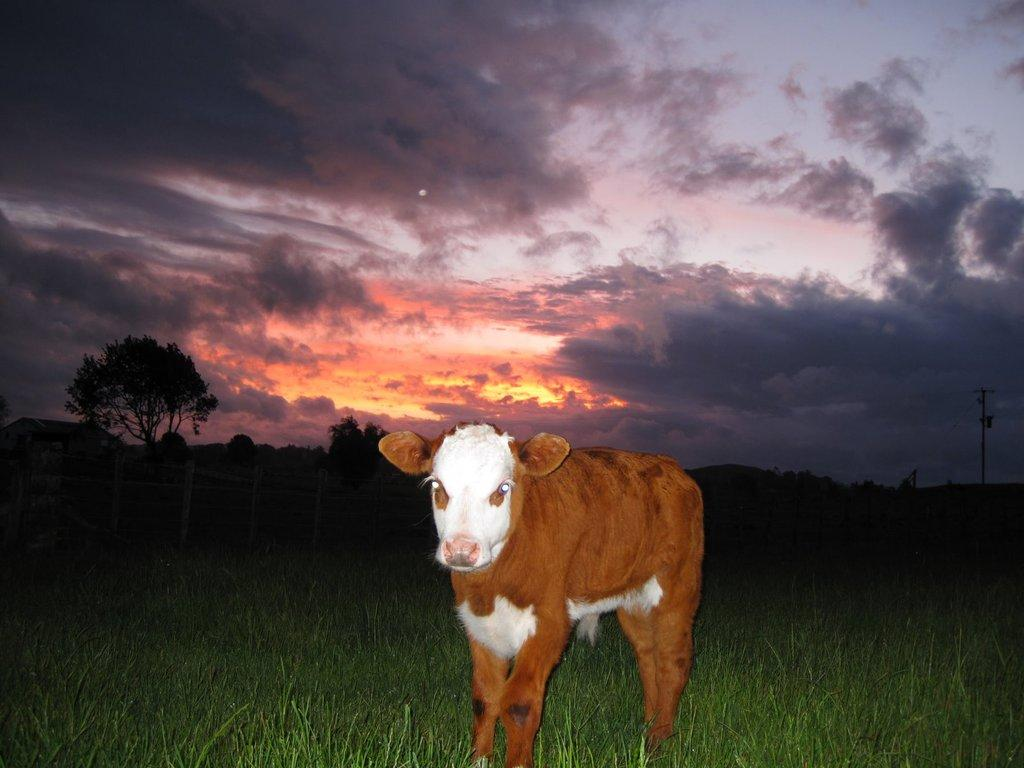What type of animal is in the image? There is a calf in the image. What can be seen in the background of the image? There are trees in the image. What is on the ground in the image? There is grass on the ground in the image. What object is present in the image that is not a living organism? There is a pole in the image. What is the condition of the sky in the image? The sky is cloudy in the image. How is the calf being used to lead the bike in the image? There is no bike present in the image, and the calf is not being used to lead anything. 